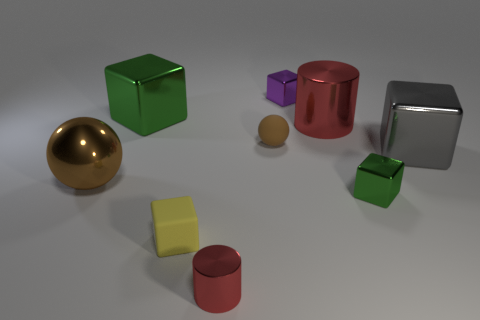Is there a purple shiny cube?
Provide a short and direct response. Yes. What number of rubber cubes have the same color as the small shiny cylinder?
Provide a succinct answer. 0. There is a big ball that is the same color as the tiny ball; what is its material?
Give a very brief answer. Metal. How big is the red shiny cylinder left of the tiny object behind the large green metallic cube?
Provide a short and direct response. Small. Are there any big brown objects that have the same material as the yellow block?
Provide a succinct answer. No. There is a brown sphere that is the same size as the yellow rubber object; what material is it?
Offer a terse response. Rubber. There is a cylinder that is right of the small purple metallic cube; does it have the same color as the tiny metallic thing that is left of the purple block?
Your answer should be very brief. Yes. Is there a big gray cube behind the rubber object behind the big brown metal ball?
Ensure brevity in your answer.  No. Does the metallic thing that is on the right side of the tiny green metallic block have the same shape as the tiny thing right of the purple shiny block?
Offer a terse response. Yes. Is the material of the green object that is in front of the large green cube the same as the green object that is behind the brown metal thing?
Ensure brevity in your answer.  Yes. 